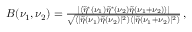Convert formula to latex. <formula><loc_0><loc_0><loc_500><loc_500>\begin{array} { r } { B ( \nu _ { 1 } , \nu _ { 2 } ) = \frac { \left | \left \langle \tilde { \eta } ^ { * } ( \nu _ { 1 } ) \tilde { \eta } ^ { * } ( \nu _ { 2 } ) \tilde { \eta } ( \nu _ { 1 } + \nu _ { 2 } ) \right \rangle \right | } { \sqrt { \langle | \tilde { \eta } ( \nu _ { 1 } ) \tilde { \eta } ( \nu _ { 2 } ) | ^ { 2 } \rangle \langle | \tilde { \eta } ( \nu _ { 1 } + \nu _ { 2 } ) | ^ { 2 } \rangle } } \, , } \end{array}</formula> 